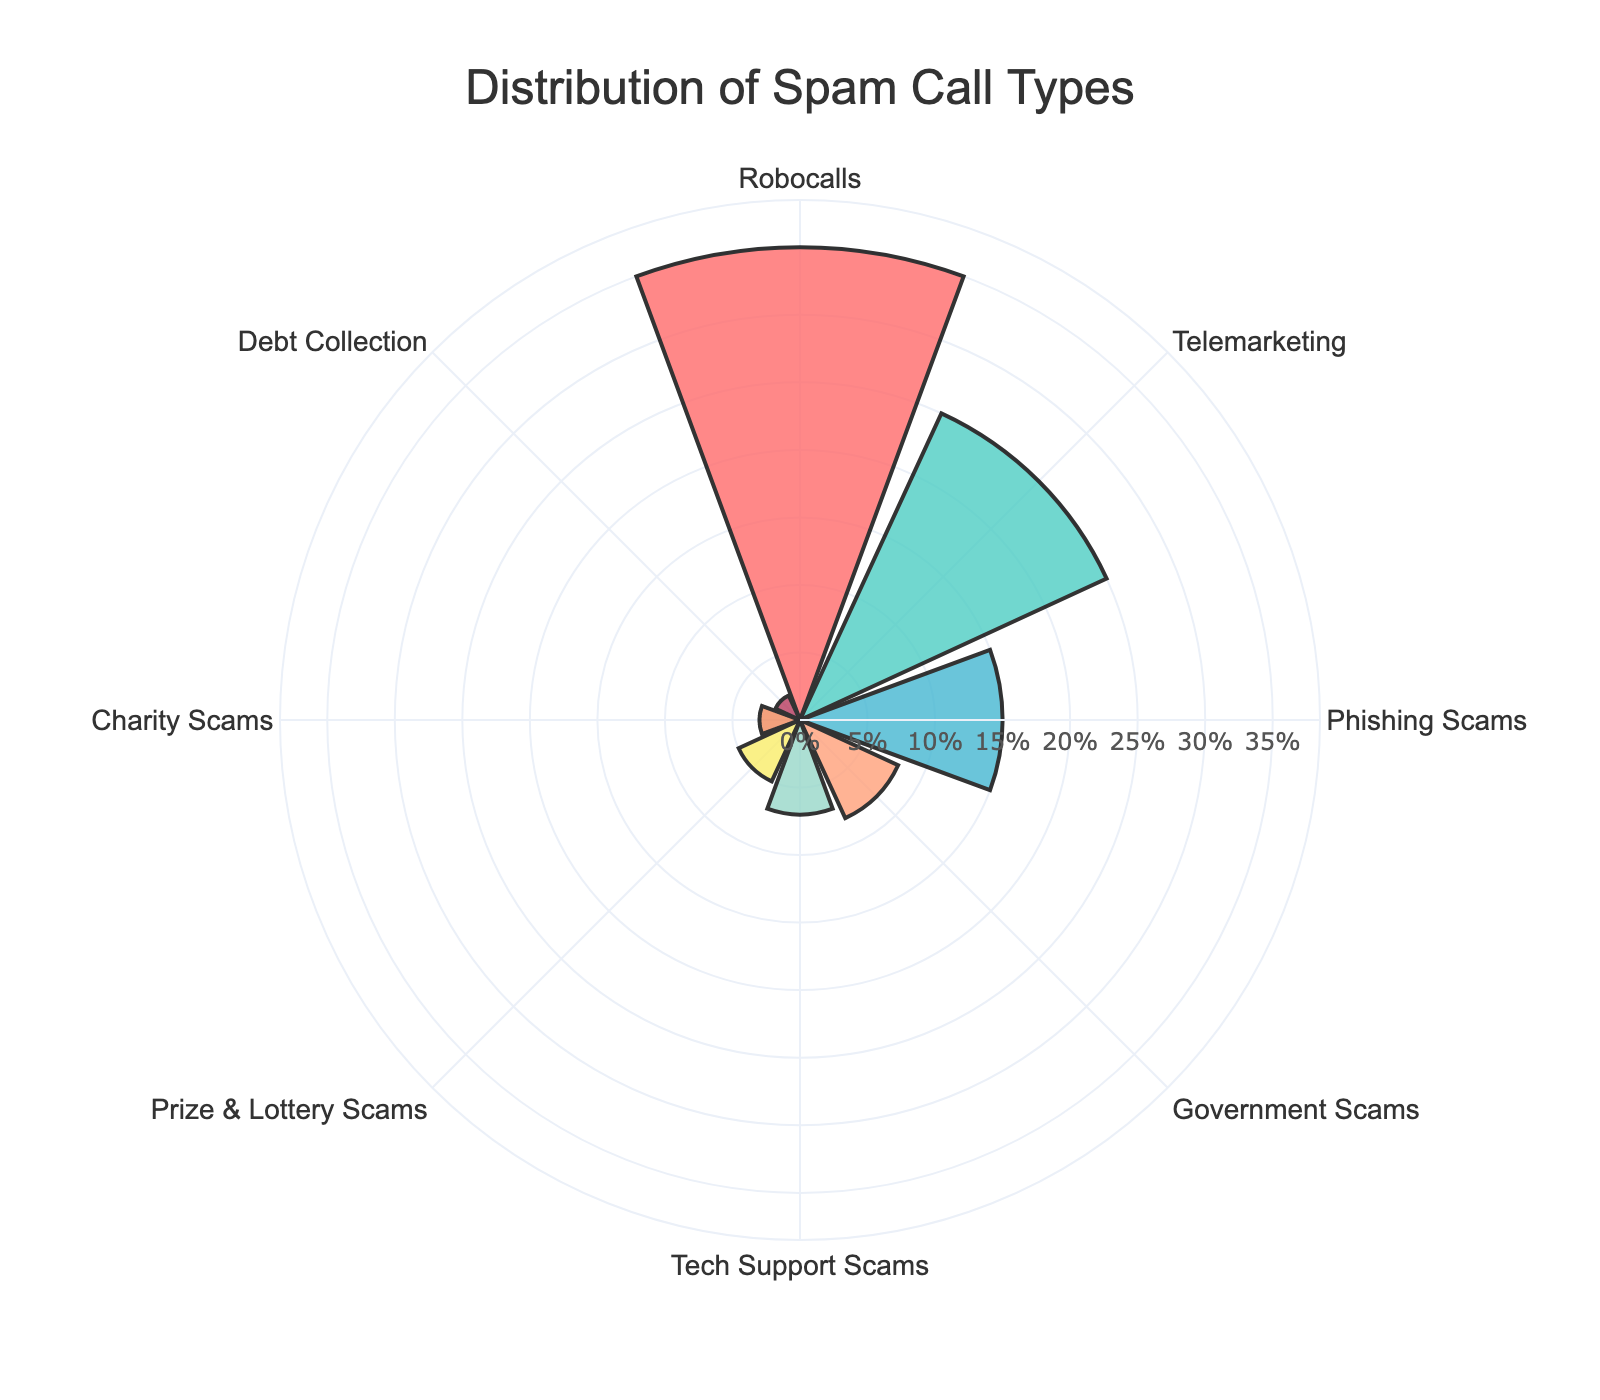what is the total percentage of robocalls and telemarketing combined? Robocalls have a percentage of 35%, and Telemarketing has 25%. Adding these two values together gives the total percentage (35% + 25%) = 60%
Answer: 60% Which category has the smallest percentage of spam calls? To find the category with the smallest percentage, compare all the values. The smallest percentage is 2%, which corresponds to Debt Collection.
Answer: Debt Collection What is the title of the figure? The title of the figure is usually displayed at the top and should describe the content of the chart. Here it is "Distribution of Spam Call Types".
Answer: Distribution of Spam Call Types Which category has a higher percentage, Tech Support Scams or Government Scams? Look at the percentages for Tech Support Scams (7%) and Government Scams (8%). Comparing these two shows that Government Scams has a higher percentage.
Answer: Government Scams How many categories have a percentage less than 10%? Identify the categories with percentages less than 10%. The qualifying categories are Government Scams (8%), Tech Support Scams (7%), Prize & Lottery Scams (5%), Charity Scams (3%), and Debt Collection (2%). This gives a total of 5 categories.
Answer: 5 By how much does the percentage of Robocalls exceed that of Phishing Scams? The percentage of Robocalls is 35% and that of Phishing Scams is 15%. Subtract the percentage of Phishing Scams from that of Robocalls (35% - 15%) = 20%
Answer: 20% How are the categories arranged around the circle? The arrangement of the categories around the circle is based on their names. They are distributed evenly in a circular pattern in the rose chart.
Answer: Circular pattern What is the difference in percentage between Prize & Lottery Scams and Charity Scams? The percentage for Prize & Lottery Scams is 5% and for Charity Scams is 3%. Subtract the percentage for Charity Scams from the percentage for Prize & Lottery Scams (5% - 3%) = 2%
Answer: 2% Which category represents more than a third of the total spam calls? To represent more than a third (1/3) of the total, the category needs a percentage greater than 33.33%. The only category that qualifies is Robocalls with 35%.
Answer: Robocalls 